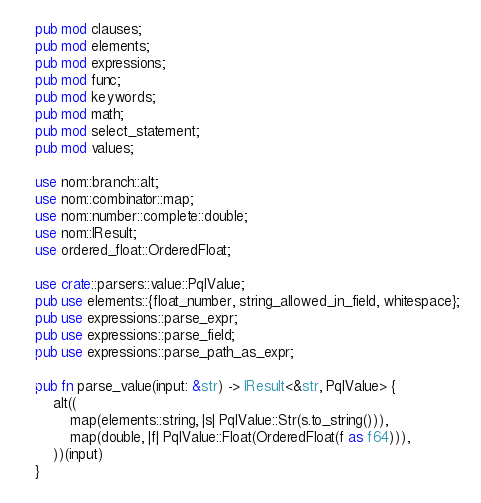<code> <loc_0><loc_0><loc_500><loc_500><_Rust_>pub mod clauses;
pub mod elements;
pub mod expressions;
pub mod func;
pub mod keywords;
pub mod math;
pub mod select_statement;
pub mod values;

use nom::branch::alt;
use nom::combinator::map;
use nom::number::complete::double;
use nom::IResult;
use ordered_float::OrderedFloat;

use crate::parsers::value::PqlValue;
pub use elements::{float_number, string_allowed_in_field, whitespace};
pub use expressions::parse_expr;
pub use expressions::parse_field;
pub use expressions::parse_path_as_expr;

pub fn parse_value(input: &str) -> IResult<&str, PqlValue> {
    alt((
        map(elements::string, |s| PqlValue::Str(s.to_string())),
        map(double, |f| PqlValue::Float(OrderedFloat(f as f64))),
    ))(input)
}
</code> 